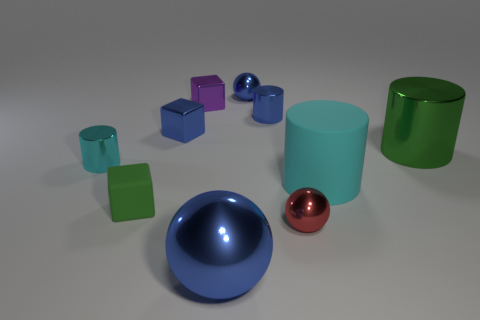Subtract all shiny cylinders. How many cylinders are left? 1 Subtract all blocks. How many objects are left? 7 Subtract all blue cylinders. How many cylinders are left? 3 Subtract 3 spheres. How many spheres are left? 0 Add 5 big cylinders. How many big cylinders exist? 7 Subtract 1 blue cylinders. How many objects are left? 9 Subtract all blue balls. Subtract all purple cubes. How many balls are left? 1 Subtract all gray cylinders. How many cyan cubes are left? 0 Subtract all tiny yellow balls. Subtract all big blue shiny objects. How many objects are left? 9 Add 8 green blocks. How many green blocks are left? 9 